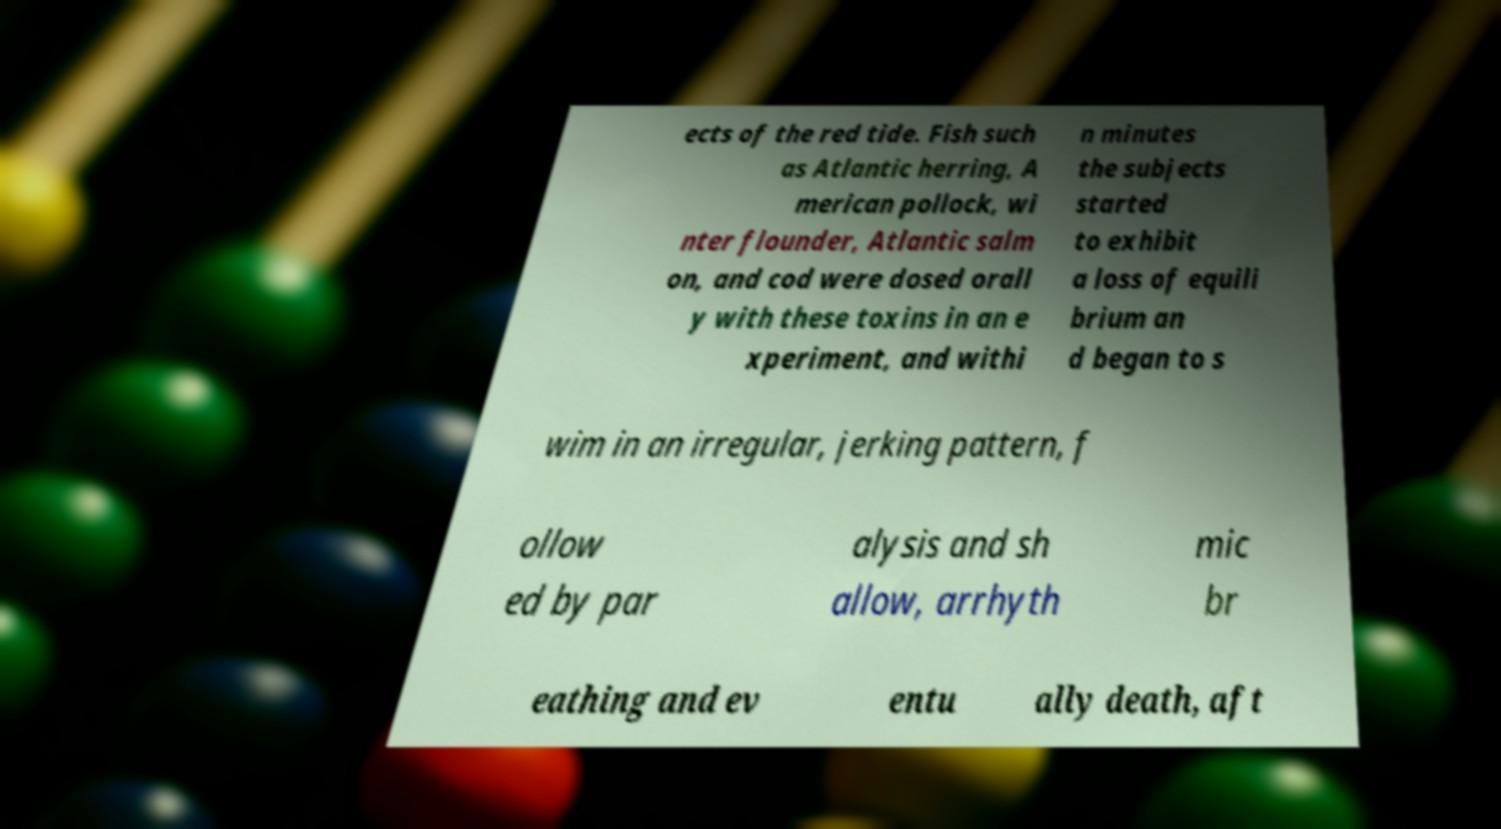Can you read and provide the text displayed in the image?This photo seems to have some interesting text. Can you extract and type it out for me? ects of the red tide. Fish such as Atlantic herring, A merican pollock, wi nter flounder, Atlantic salm on, and cod were dosed orall y with these toxins in an e xperiment, and withi n minutes the subjects started to exhibit a loss of equili brium an d began to s wim in an irregular, jerking pattern, f ollow ed by par alysis and sh allow, arrhyth mic br eathing and ev entu ally death, aft 